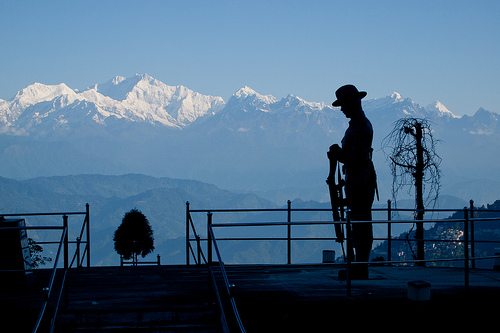<image>
Is there a snow under the sky? Yes. The snow is positioned underneath the sky, with the sky above it in the vertical space. 